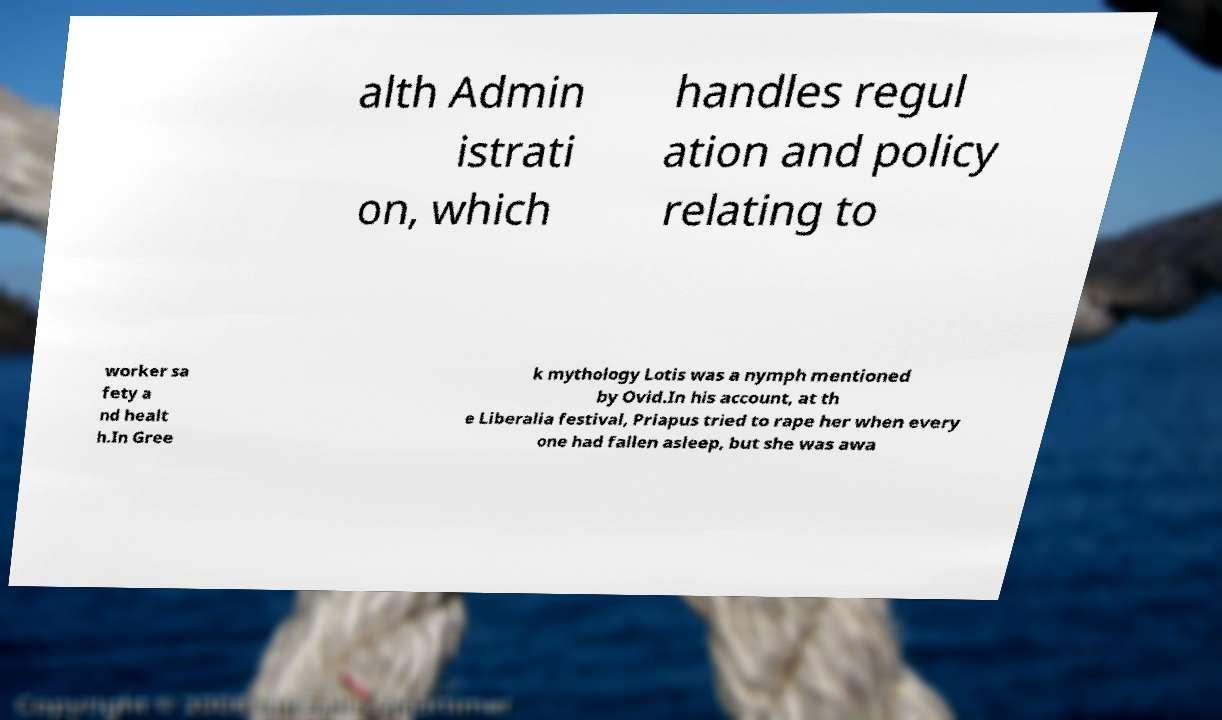Please identify and transcribe the text found in this image. alth Admin istrati on, which handles regul ation and policy relating to worker sa fety a nd healt h.In Gree k mythology Lotis was a nymph mentioned by Ovid.In his account, at th e Liberalia festival, Priapus tried to rape her when every one had fallen asleep, but she was awa 